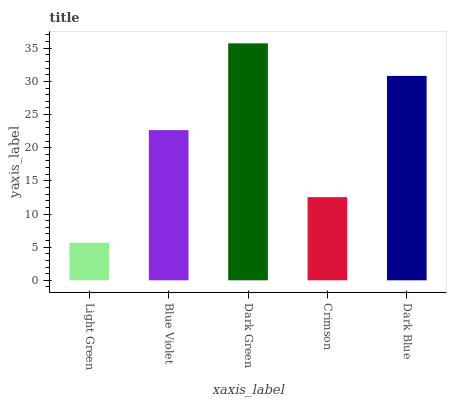Is Light Green the minimum?
Answer yes or no. Yes. Is Dark Green the maximum?
Answer yes or no. Yes. Is Blue Violet the minimum?
Answer yes or no. No. Is Blue Violet the maximum?
Answer yes or no. No. Is Blue Violet greater than Light Green?
Answer yes or no. Yes. Is Light Green less than Blue Violet?
Answer yes or no. Yes. Is Light Green greater than Blue Violet?
Answer yes or no. No. Is Blue Violet less than Light Green?
Answer yes or no. No. Is Blue Violet the high median?
Answer yes or no. Yes. Is Blue Violet the low median?
Answer yes or no. Yes. Is Dark Green the high median?
Answer yes or no. No. Is Light Green the low median?
Answer yes or no. No. 